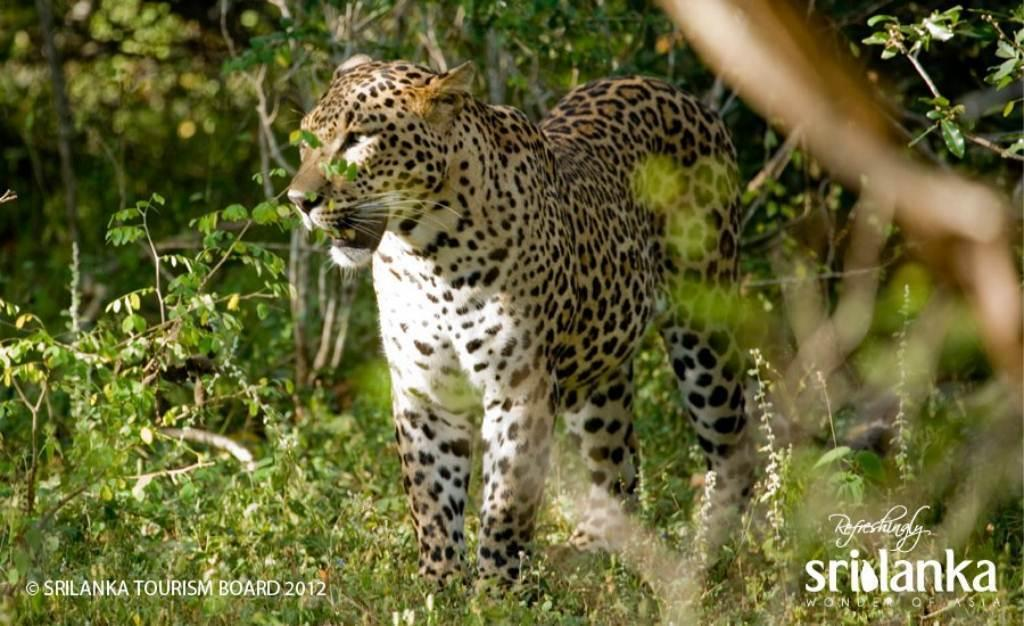What type of animal is in the image? The type of animal cannot be determined from the provided facts. What can be seen in the background of the image? There are trees in the background of the image. What is present at the bottom of the image? There is text at the bottom of the image. What type of news is being reported in the office in the image? There is no office or news present in the image; it features an animal and trees in the background. 